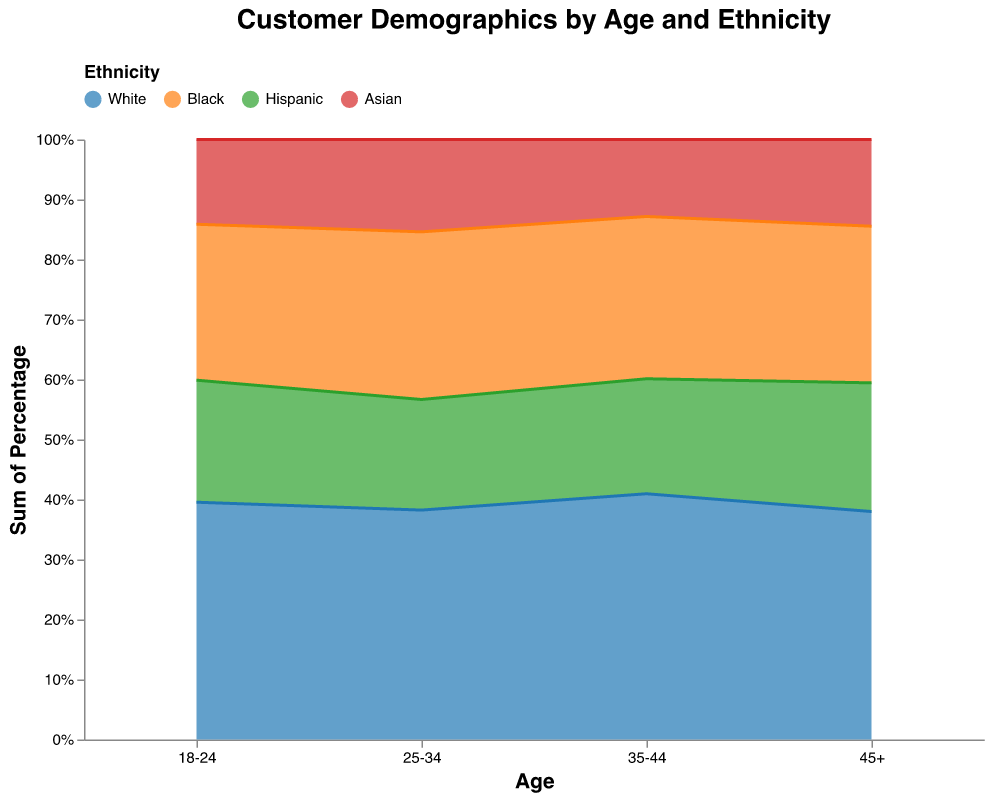What are the age groups represented in the chart? The x-axis of the chart represents age groups, which can be seen having labels for each distinct age range. By looking at the x-axis, we can see the age groups represented.
Answer: 18-24, 25-34, 35-44, 45+ Which ethnicity has the highest percentage in the 25-34 age group? By examining the largest stacked area for each section on the x-axis corresponding to "25-34", we can visually identify which color (ethnicity) occupies the most space vertically.
Answer: White How does the percentage of Hispanic customers change from age group 18-24 to 45+? To determine this, we observe the height of the green (Hispanic) area in each of the age group segments on the x-axis. For age group 18-24, it is approximately 18%. For age group 45+, it appears around 9%. Calculating the difference, we find that the percentage decreases.
Answer: Decreases by 9% Compare the percentage of male and female Black customers in the 35-44 age group. We need to identify the stacked areas representing Black customers in the 35-44 age group and compare the orange sections corresponding to male and female. The chart shows male at 8% and female at 9%.
Answer: Female Black customers are 1% higher What is the total percentage of Asian customers in the 45+ age group? Adding the percentages of all gender categories (male, female, and non-binary) for Asian customers in the 45+ age group. Male is 3%, female is 3%, and non-binary is 0.2%. Summing these gives the total.
Answer: 6.2% Which age group has the largest representation of non-binary customers across all ethnicities? We need to look at the non-binary sections for each age group and find out which has the highest combined value across all ethnicities. Observing the data, the 18-24 and 25-34 age groups have noticeable non-binary populations. After summing for each group, 18-24 is highest.
Answer: 18-24 Are there more Hispanic female customers in the 25-34 age group or Asian female customers in the same age group? By comparing the height of the relevant segments in the 25-34 age group, we see that both percentages are represented by the green (Hispanic) and red (Asian) colors. Hispanic female is 9% and Asian female is 8%.
Answer: Hispanic female customers What is the trend of the percentage of White customers as age increases? By following the blue (White) sections across the x-axis from 18-24 to 45+, we can observe if the percentage increases, decreases, or stays constant.
Answer: Decreasing trend Which gender has the smallest representation in each age group? By evaluating the width of the stacked areas for males, females, and non-binary in each age group, we can see that the smallest areas are consistently the non-binary sections.
Answer: Non-Binary in all groups What is the combined percentage of Black customers across all age groups? To compute this, we add all percentages of Black customers for each age group and gender from the stacked areas. Summing 10, 12, 1, 12, 15, 1.5, 8, 9, 0.5, 5, 6, and 0.2 gives a total.
Answer: 80.2% 